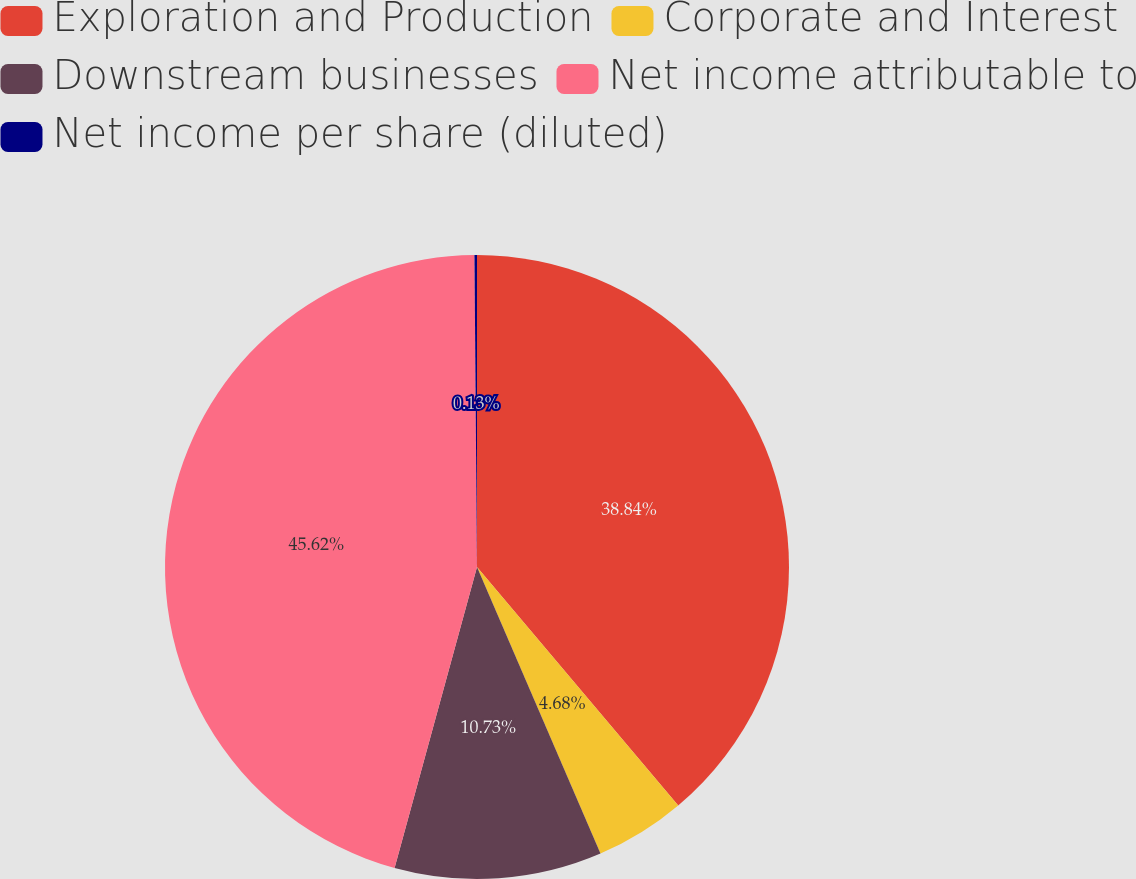<chart> <loc_0><loc_0><loc_500><loc_500><pie_chart><fcel>Exploration and Production<fcel>Corporate and Interest<fcel>Downstream businesses<fcel>Net income attributable to<fcel>Net income per share (diluted)<nl><fcel>38.84%<fcel>4.68%<fcel>10.73%<fcel>45.61%<fcel>0.13%<nl></chart> 